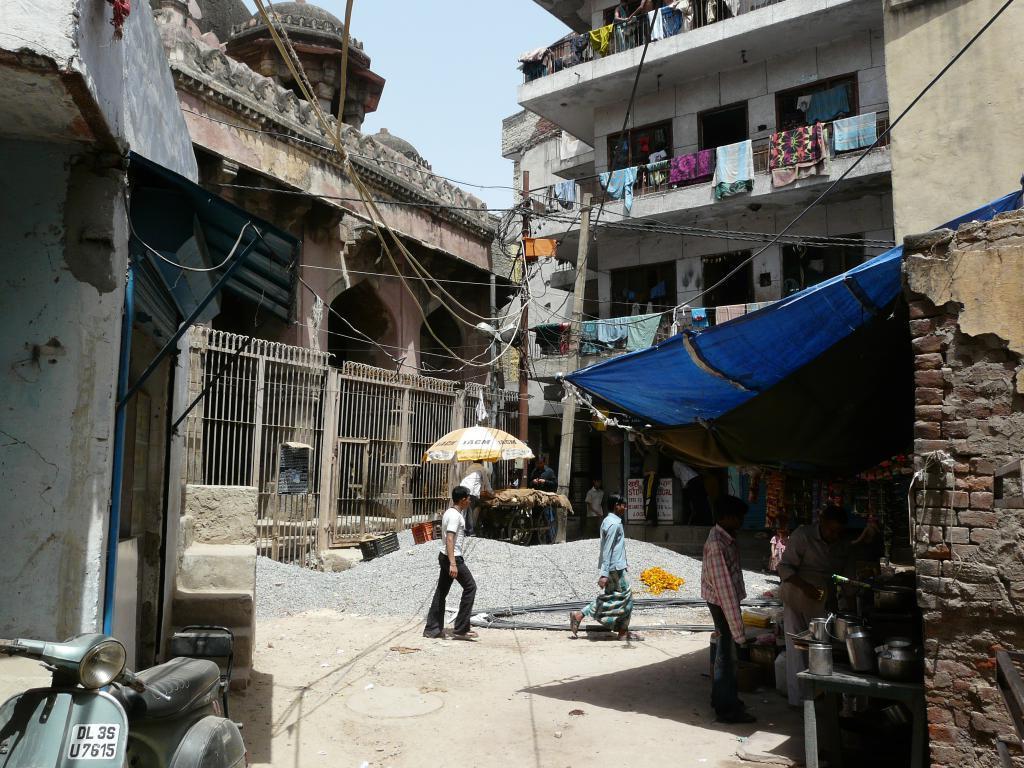Describe this image in one or two sentences. This is clicked in a street, there are few women walking on the road and in the back there are buildings with traffic poles in front and clothes hanging to the buildings and above its sky. 